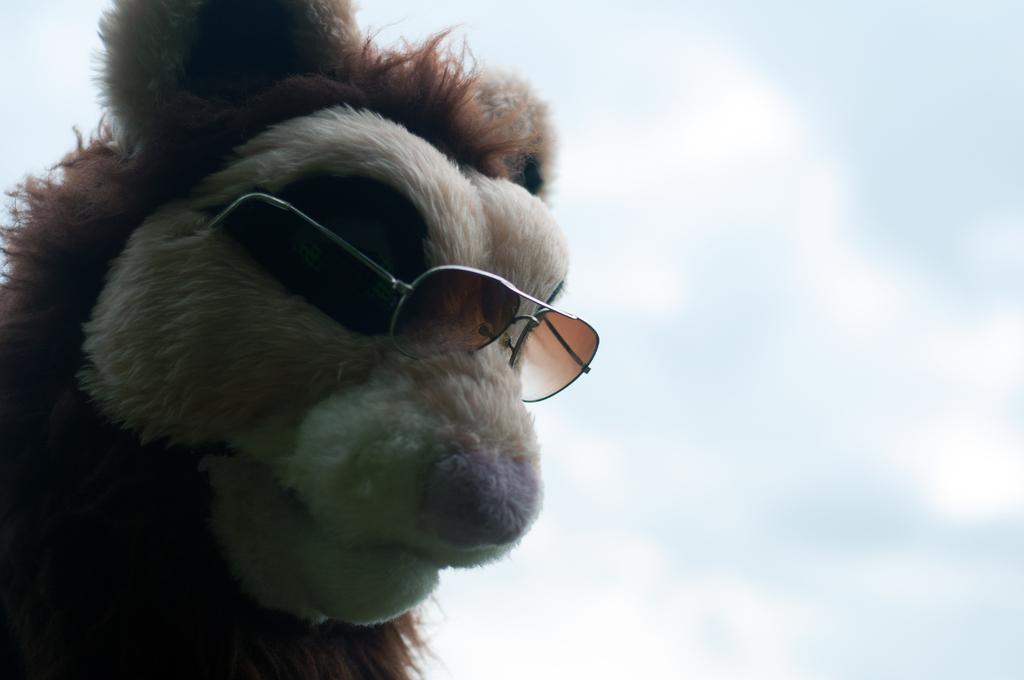Please provide a concise description of this image. In the foreground of this picture, we see a toy wearing spectacles. In the background, we see the sky. 